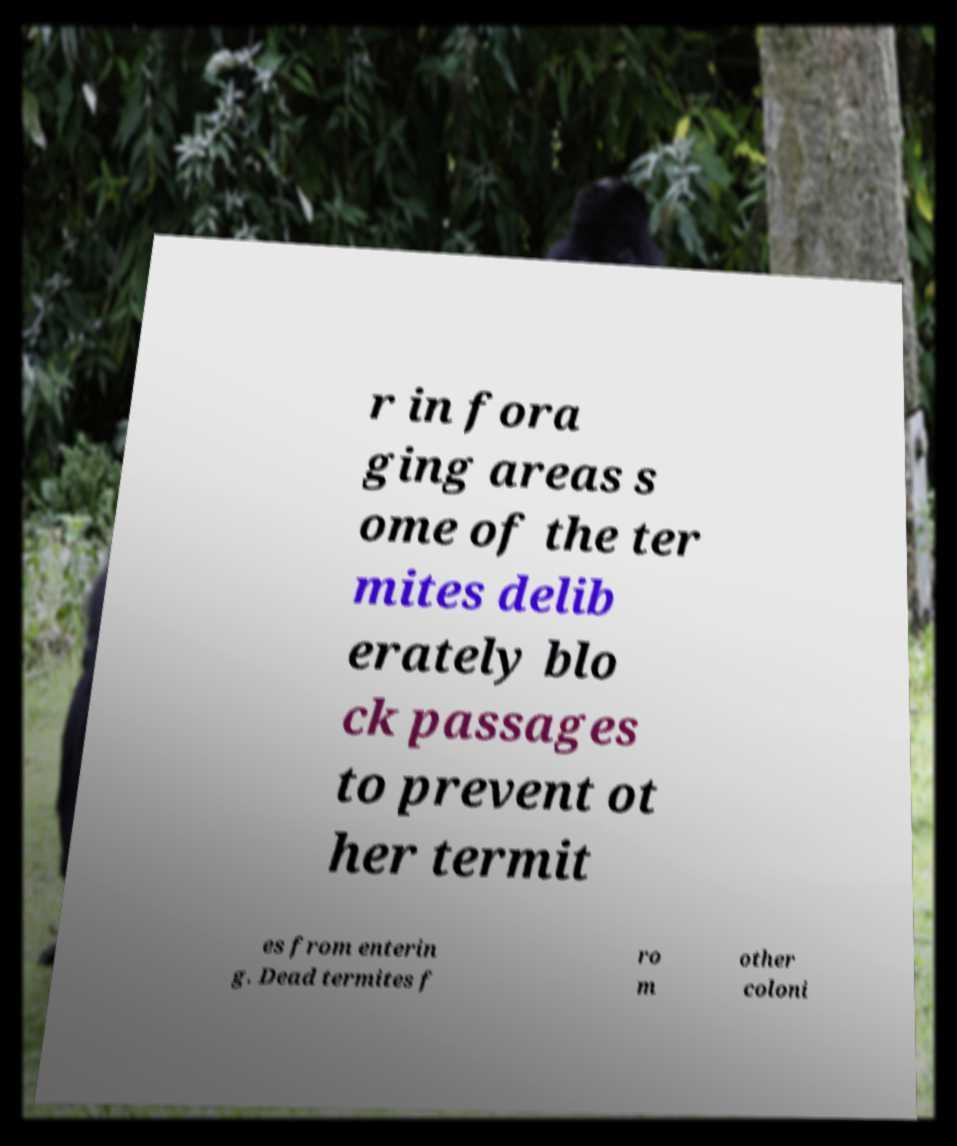For documentation purposes, I need the text within this image transcribed. Could you provide that? r in fora ging areas s ome of the ter mites delib erately blo ck passages to prevent ot her termit es from enterin g. Dead termites f ro m other coloni 